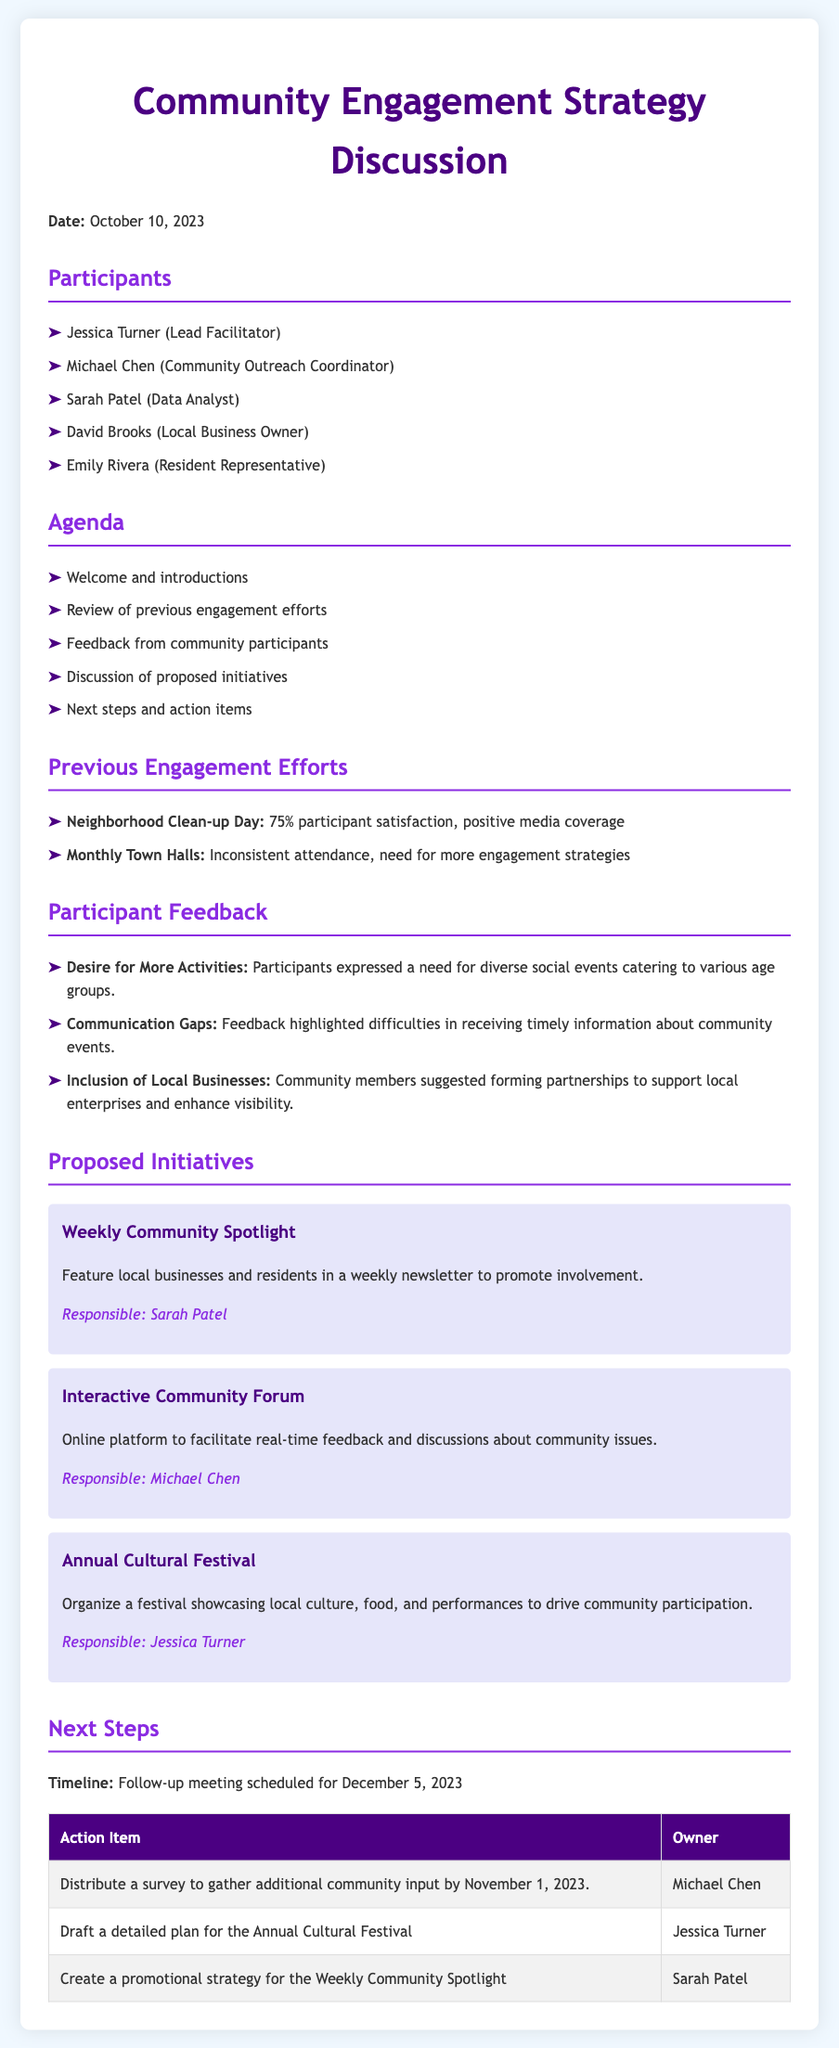What is the date of the meeting? The meeting took place on October 10, 2023, as stated at the beginning of the document.
Answer: October 10, 2023 Who is the Lead Facilitator? Jessica Turner is identified as the Lead Facilitator in the list of participants.
Answer: Jessica Turner What was the participant satisfaction percentage for the Neighborhood Clean-up Day? The document states that the participant satisfaction for the Neighborhood Clean-up Day was 75%.
Answer: 75% What community initiative involves an online platform? The initiative that involves an online platform for feedback is the Interactive Community Forum, mentioned in the section on proposed initiatives.
Answer: Interactive Community Forum Which participant is responsible for the Annual Cultural Festival? Jessica Turner is responsible for organizing the Annual Cultural Festival, as indicated in the proposed initiatives section.
Answer: Jessica Turner What is a major concern highlighted by community participants? Participants expressed a need for diverse social events catering to various age groups, which is noted in the feedback section.
Answer: Desire for More Activities When is the follow-up meeting scheduled? The follow-up meeting is scheduled for December 5, 2023, as mentioned in the next steps section.
Answer: December 5, 2023 What is the action item due by November 1, 2023? The action item that is due by November 1, 2023, is to distribute a survey to gather additional community input.
Answer: Distribute a survey What is the purpose of the Weekly Community Spotlight initiative? The purpose of the Weekly Community Spotlight initiative is to feature local businesses and residents in a weekly newsletter to promote involvement.
Answer: Promote involvement 